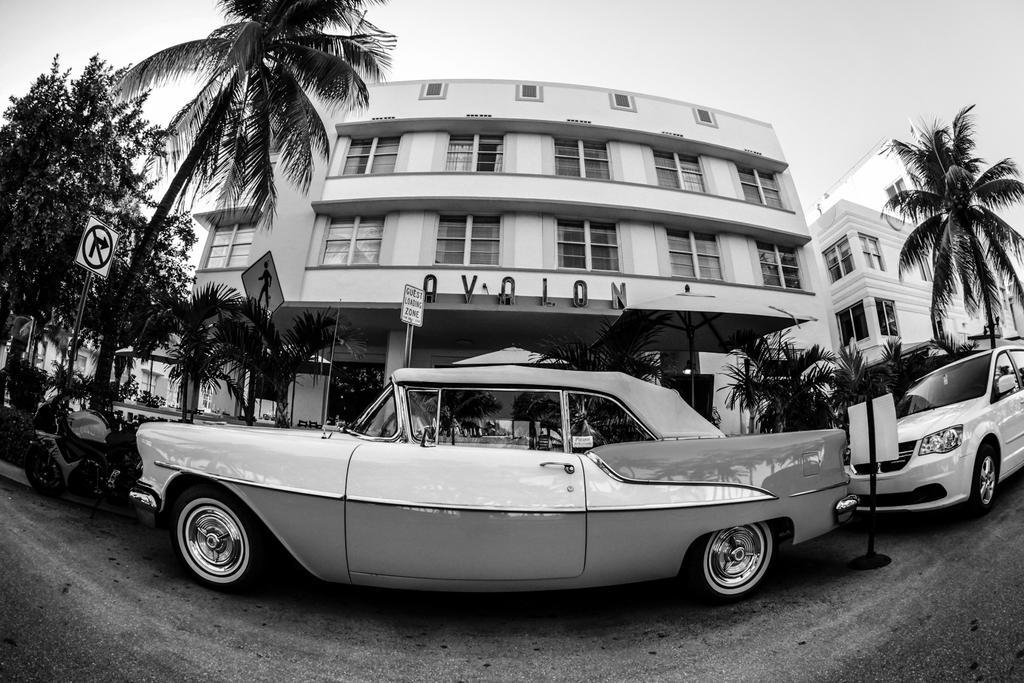How would you summarize this image in a sentence or two? In front of the image there are cars and bike parked, beside them there are sign boards, in the background of the image there are trees and buildings, on the building there is name. 